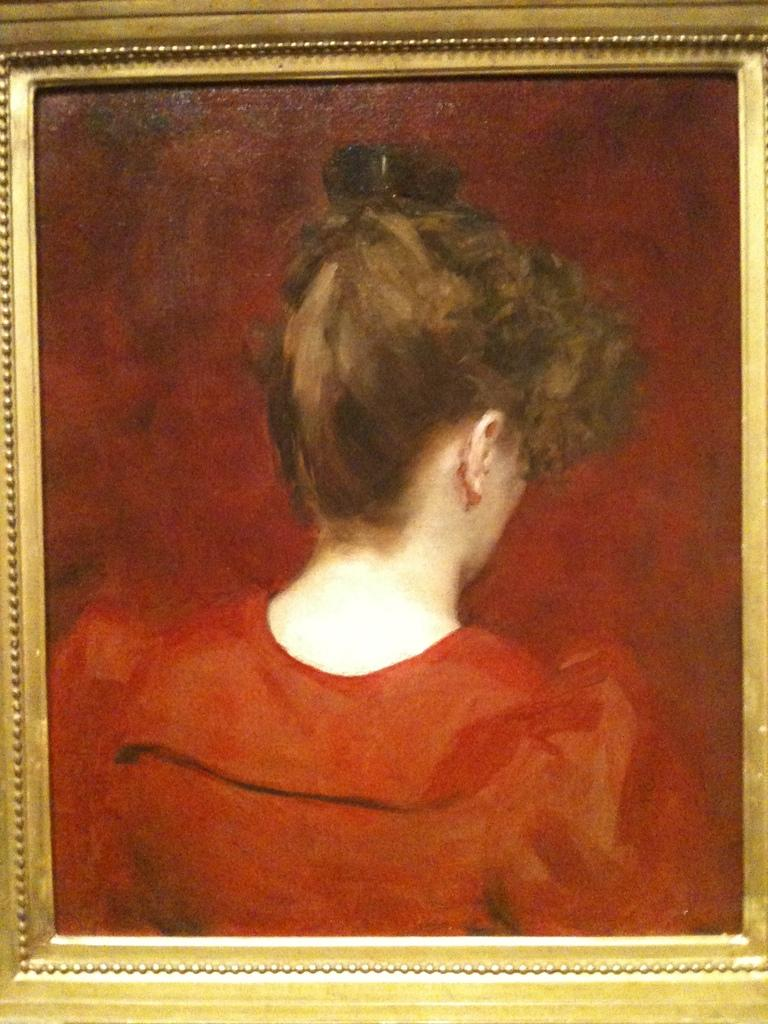What object is present in the image that holds a visual representation? There is a photo frame in the image. What is displayed within the photo frame? The photo frame contains a painting. Can you describe the subject of the painting? The painting features a woman. What is the woman wearing in the painting? The woman is wearing an orange dress. What is the color of the background in the painting? The background of the painting is brown in color. What type of sign can be seen in the painting? There is no sign present in the painting; it features a woman wearing an orange dress with a brown background. 